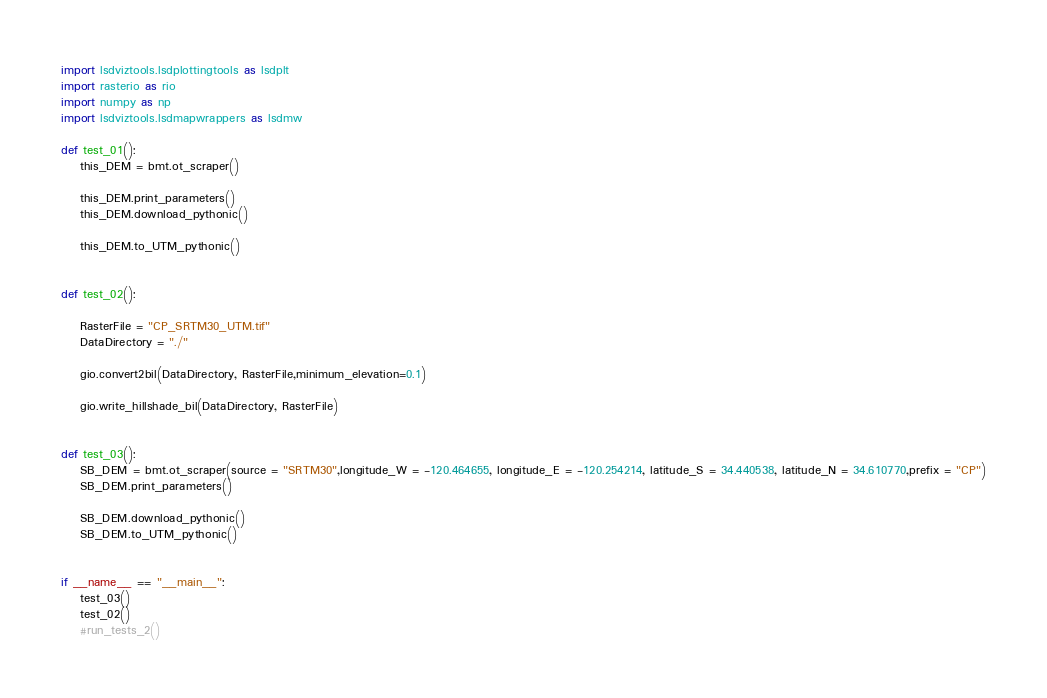Convert code to text. <code><loc_0><loc_0><loc_500><loc_500><_Python_>import lsdviztools.lsdplottingtools as lsdplt
import rasterio as rio
import numpy as np
import lsdviztools.lsdmapwrappers as lsdmw

def test_01():
    this_DEM = bmt.ot_scraper()

    this_DEM.print_parameters()
    this_DEM.download_pythonic()

    this_DEM.to_UTM_pythonic()


def test_02():

    RasterFile = "CP_SRTM30_UTM.tif"
    DataDirectory = "./"

    gio.convert2bil(DataDirectory, RasterFile,minimum_elevation=0.1)

    gio.write_hillshade_bil(DataDirectory, RasterFile)


def test_03():
    SB_DEM = bmt.ot_scraper(source = "SRTM30",longitude_W = -120.464655, longitude_E = -120.254214, latitude_S = 34.440538, latitude_N = 34.610770,prefix = "CP")
    SB_DEM.print_parameters()

    SB_DEM.download_pythonic()
    SB_DEM.to_UTM_pythonic()


if __name__ == "__main__":
    test_03()
    test_02()
    #run_tests_2()
</code> 